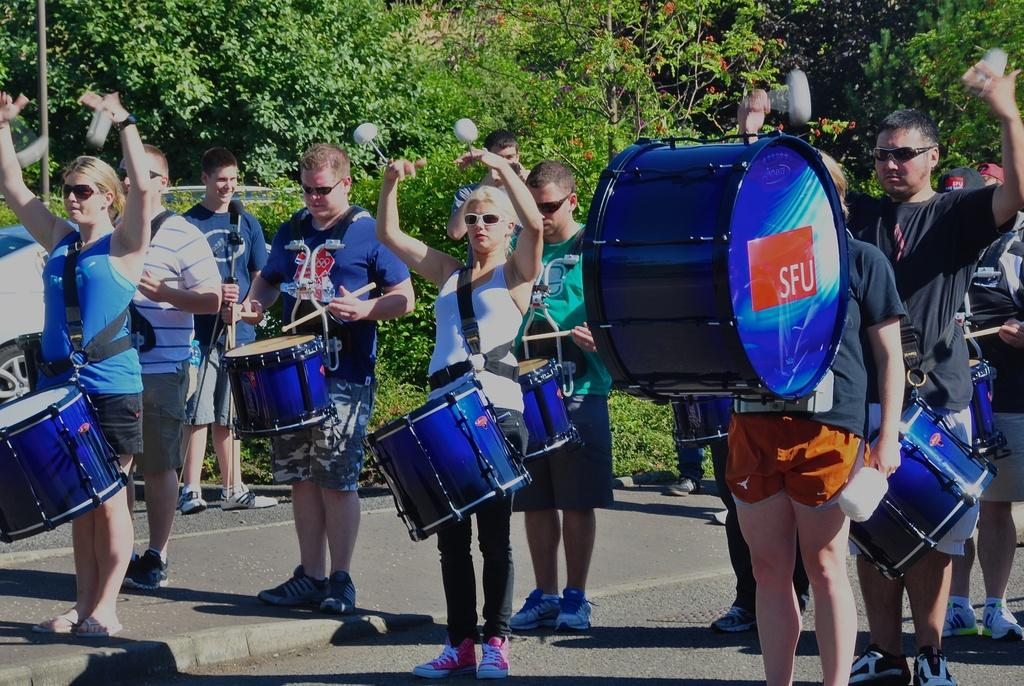What are the people in the image doing? The people in the image are playing musical instruments. What can be seen in the background of the image? There are many trees in the image. Where is the vehicle located in the image? The vehicle is at the left side of the image. What type of mist can be seen surrounding the people playing musical instruments in the image? There is no mist present in the image; the people are playing musical instruments in a clear setting. 